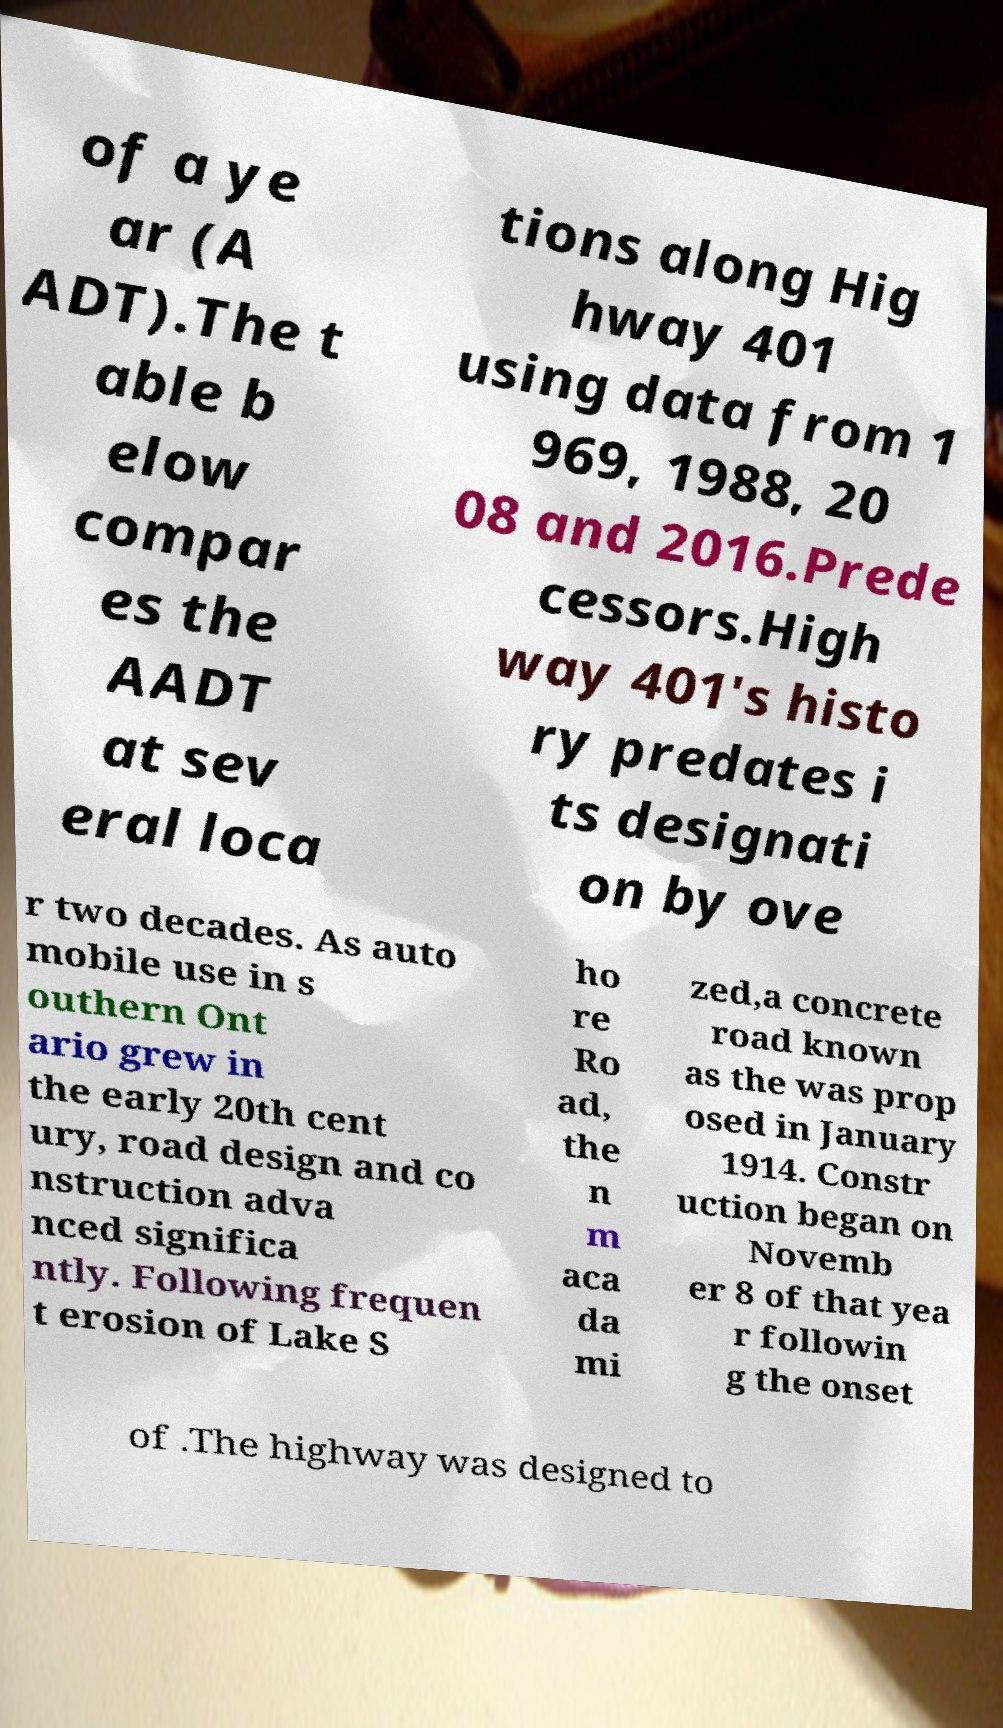Can you accurately transcribe the text from the provided image for me? of a ye ar (A ADT).The t able b elow compar es the AADT at sev eral loca tions along Hig hway 401 using data from 1 969, 1988, 20 08 and 2016.Prede cessors.High way 401's histo ry predates i ts designati on by ove r two decades. As auto mobile use in s outhern Ont ario grew in the early 20th cent ury, road design and co nstruction adva nced significa ntly. Following frequen t erosion of Lake S ho re Ro ad, the n m aca da mi zed,a concrete road known as the was prop osed in January 1914. Constr uction began on Novemb er 8 of that yea r followin g the onset of .The highway was designed to 